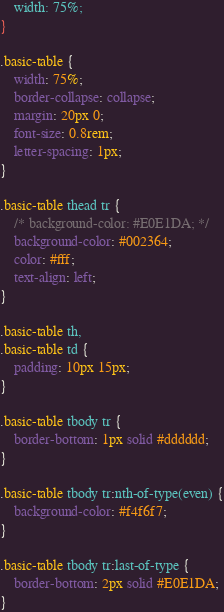Convert code to text. <code><loc_0><loc_0><loc_500><loc_500><_CSS_>    width: 75%;
}

.basic-table {
    width: 75%;
    border-collapse: collapse;
    margin: 20px 0;
    font-size: 0.8rem;
    letter-spacing: 1px;
}

.basic-table thead tr {
    /* background-color: #E0E1DA; */
    background-color: #002364;
    color: #fff;
    text-align: left;
}

.basic-table th,
.basic-table td {
    padding: 10px 15px;
}

.basic-table tbody tr {
    border-bottom: 1px solid #dddddd;
}

.basic-table tbody tr:nth-of-type(even) {
    background-color: #f4f6f7;
}

.basic-table tbody tr:last-of-type {
    border-bottom: 2px solid #E0E1DA;
}</code> 